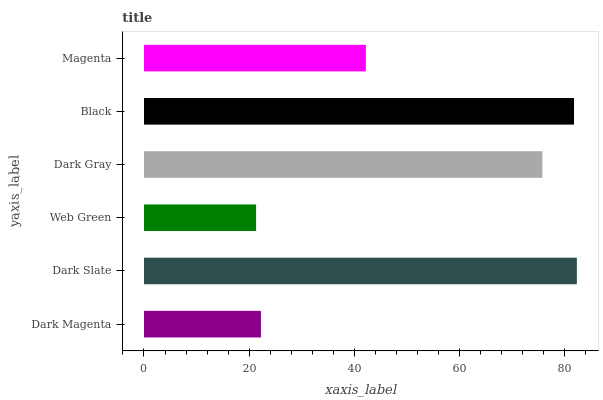Is Web Green the minimum?
Answer yes or no. Yes. Is Dark Slate the maximum?
Answer yes or no. Yes. Is Dark Slate the minimum?
Answer yes or no. No. Is Web Green the maximum?
Answer yes or no. No. Is Dark Slate greater than Web Green?
Answer yes or no. Yes. Is Web Green less than Dark Slate?
Answer yes or no. Yes. Is Web Green greater than Dark Slate?
Answer yes or no. No. Is Dark Slate less than Web Green?
Answer yes or no. No. Is Dark Gray the high median?
Answer yes or no. Yes. Is Magenta the low median?
Answer yes or no. Yes. Is Magenta the high median?
Answer yes or no. No. Is Dark Gray the low median?
Answer yes or no. No. 